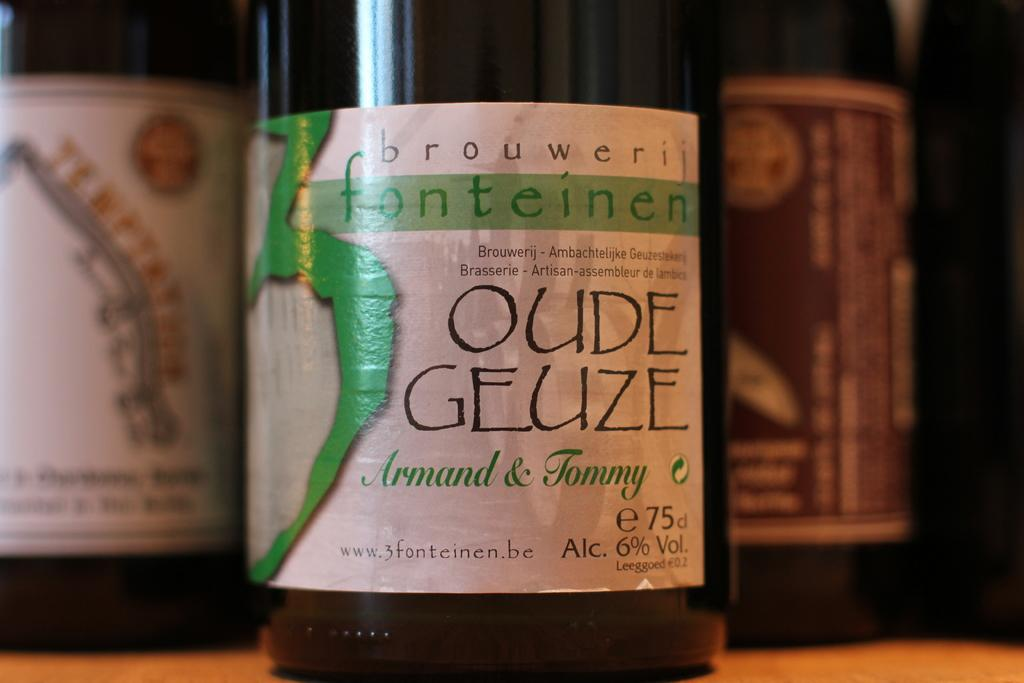<image>
Render a clear and concise summary of the photo. A dark colored bottle with a label that says Oude Geuze. 